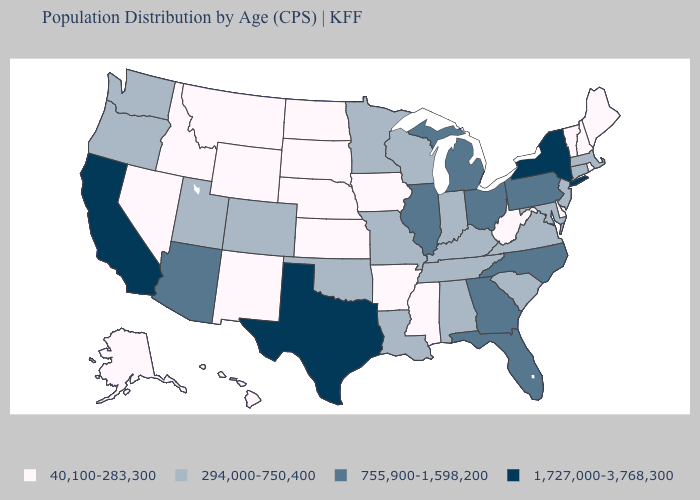What is the lowest value in the MidWest?
Keep it brief. 40,100-283,300. Does Michigan have the highest value in the MidWest?
Answer briefly. Yes. What is the value of Montana?
Give a very brief answer. 40,100-283,300. Name the states that have a value in the range 40,100-283,300?
Answer briefly. Alaska, Arkansas, Delaware, Hawaii, Idaho, Iowa, Kansas, Maine, Mississippi, Montana, Nebraska, Nevada, New Hampshire, New Mexico, North Dakota, Rhode Island, South Dakota, Vermont, West Virginia, Wyoming. Which states have the highest value in the USA?
Concise answer only. California, New York, Texas. What is the value of Maine?
Quick response, please. 40,100-283,300. Does Nevada have the same value as Vermont?
Short answer required. Yes. What is the lowest value in states that border Michigan?
Keep it brief. 294,000-750,400. Name the states that have a value in the range 294,000-750,400?
Write a very short answer. Alabama, Colorado, Connecticut, Indiana, Kentucky, Louisiana, Maryland, Massachusetts, Minnesota, Missouri, New Jersey, Oklahoma, Oregon, South Carolina, Tennessee, Utah, Virginia, Washington, Wisconsin. Does the map have missing data?
Be succinct. No. What is the highest value in states that border Wyoming?
Keep it brief. 294,000-750,400. Does the first symbol in the legend represent the smallest category?
Short answer required. Yes. Does Georgia have a higher value than South Carolina?
Write a very short answer. Yes. Does North Carolina have the lowest value in the South?
Give a very brief answer. No. What is the value of Alabama?
Be succinct. 294,000-750,400. 